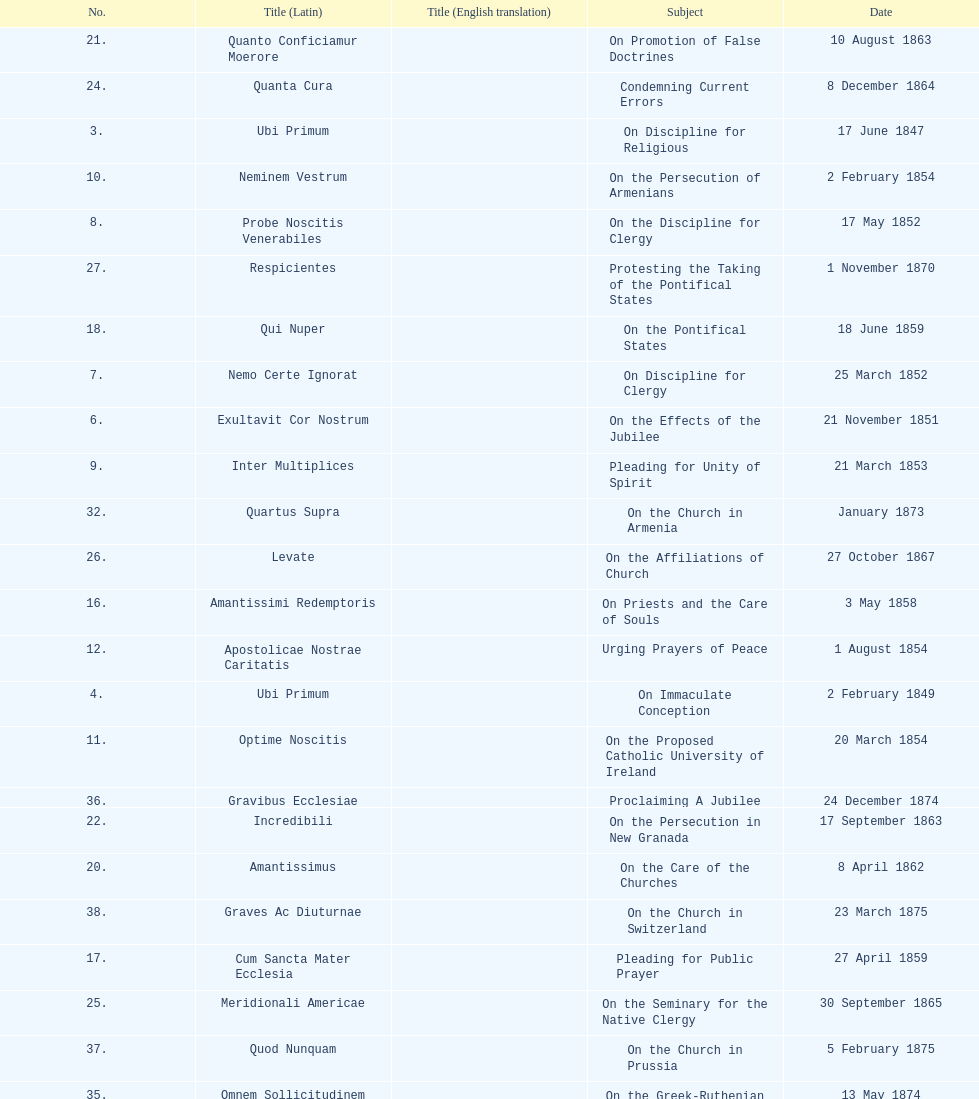How many encyclicals were issued between august 15, 1854 and october 26, 1867? 13. 